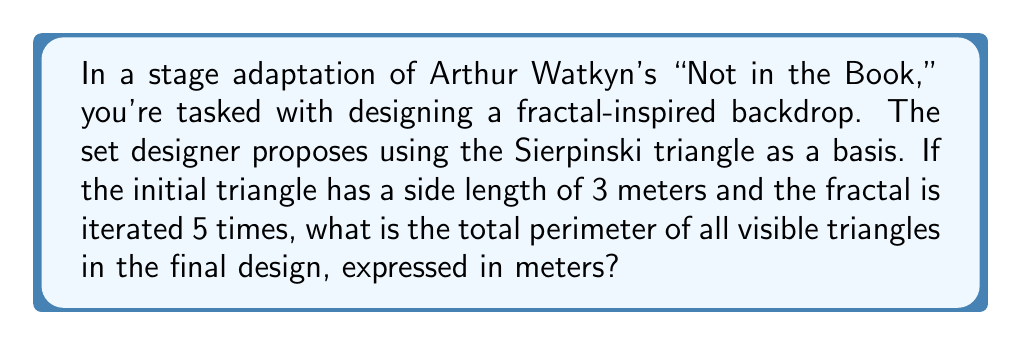Solve this math problem. Let's approach this step-by-step:

1) The Sierpinski triangle is created by repeatedly removing the central triangle from each remaining triangle.

2) In each iteration, the number of triangles triples, and their side lengths halve.

3) Let's calculate the number of triangles and their side lengths for each iteration:
   Iteration 0: 1 triangle, side length 3 m
   Iteration 1: 3 triangles, side length 1.5 m
   Iteration 2: 9 triangles, side length 0.75 m
   Iteration 3: 27 triangles, side length 0.375 m
   Iteration 4: 81 triangles, side length 0.1875 m
   Iteration 5: 243 triangles, side length 0.09375 m

4) The total number of triangles after 5 iterations is:
   $$ N = 3^5 = 243 $$

5) The side length of each smallest triangle is:
   $$ L = 3 \cdot (\frac{1}{2})^5 = 3 \cdot \frac{1}{32} = 0.09375 \text{ m} $$

6) The perimeter of each smallest triangle is:
   $$ P = 3L = 3 \cdot 0.09375 = 0.28125 \text{ m} $$

7) The total perimeter is the number of triangles multiplied by the perimeter of each:
   $$ \text{Total Perimeter} = N \cdot P = 243 \cdot 0.28125 = 68.34375 \text{ m} $$
Answer: 68.34375 m 